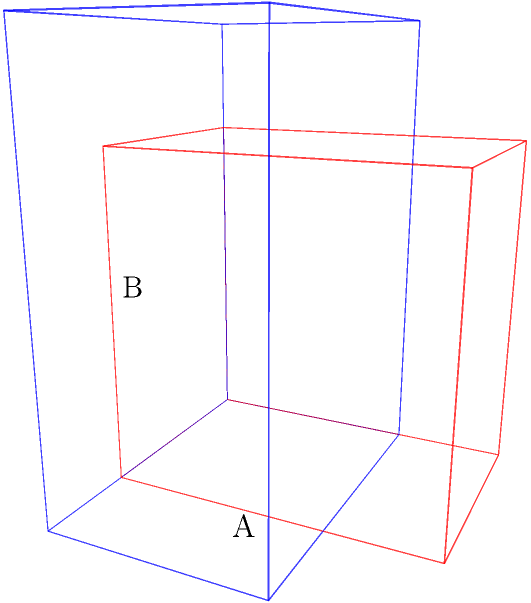Two storage containers are available for storing dry goods in the soup kitchen. Container A is a rectangular prism measuring 3 feet long, 2 feet wide, and 4 feet tall. Container B is also a rectangular prism measuring 2 feet long, 3 feet wide, and 3 feet tall. Which container has the larger volume, and by how many cubic feet? To solve this problem, we need to calculate the volume of each container and compare them:

1. Calculate the volume of Container A:
   $V_A = length \times width \times height$
   $V_A = 3 \text{ ft} \times 2 \text{ ft} \times 4 \text{ ft} = 24 \text{ ft}^3$

2. Calculate the volume of Container B:
   $V_B = length \times width \times height$
   $V_B = 2 \text{ ft} \times 3 \text{ ft} \times 3 \text{ ft} = 18 \text{ ft}^3$

3. Compare the volumes:
   $V_A - V_B = 24 \text{ ft}^3 - 18 \text{ ft}^3 = 6 \text{ ft}^3$

Therefore, Container A has the larger volume, and the difference in volume is 6 cubic feet.
Answer: Container A, 6 ft³ 